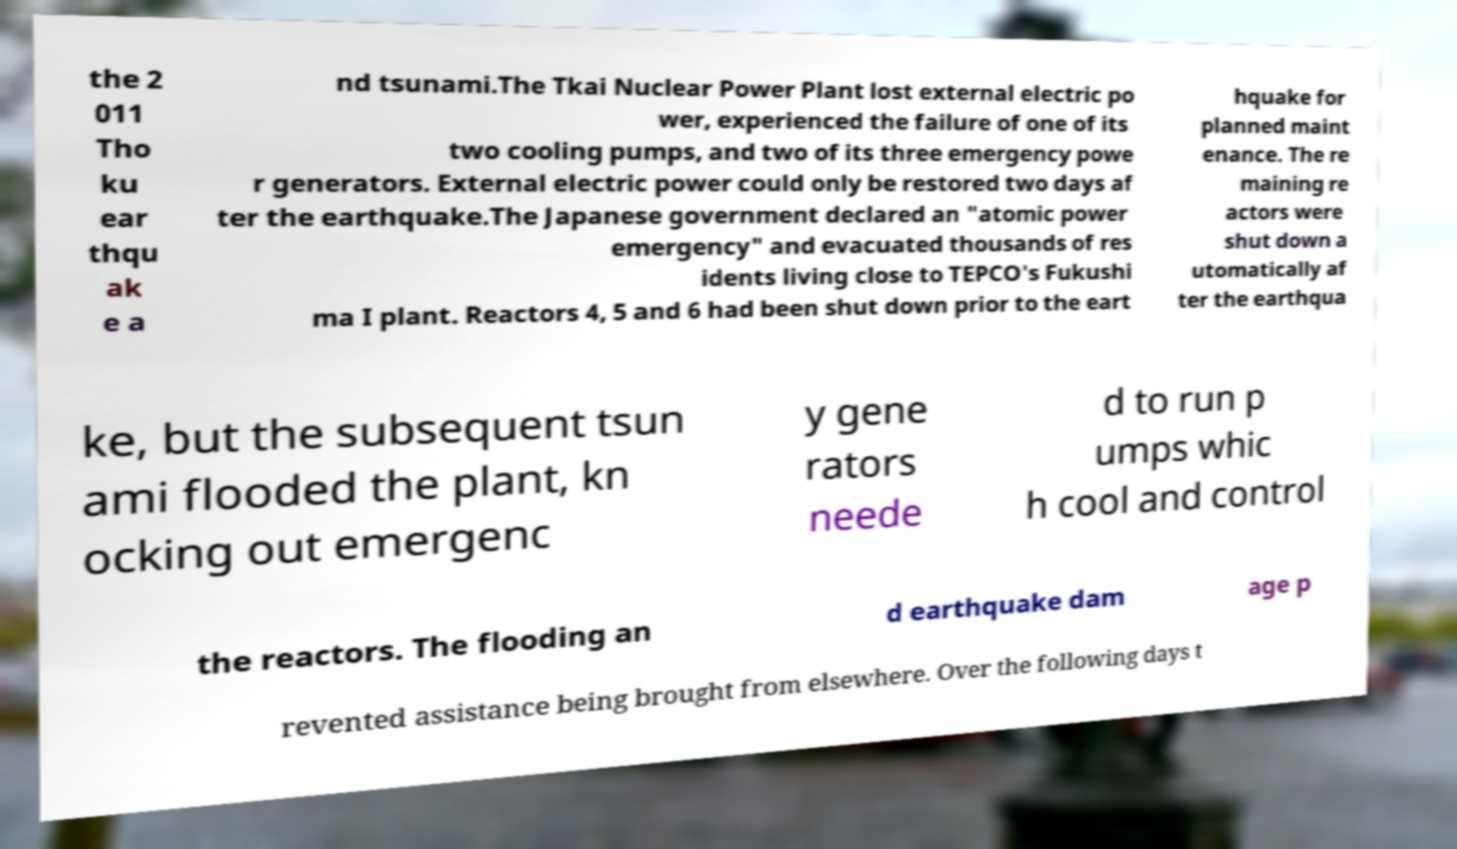Please identify and transcribe the text found in this image. the 2 011 Tho ku ear thqu ak e a nd tsunami.The Tkai Nuclear Power Plant lost external electric po wer, experienced the failure of one of its two cooling pumps, and two of its three emergency powe r generators. External electric power could only be restored two days af ter the earthquake.The Japanese government declared an "atomic power emergency" and evacuated thousands of res idents living close to TEPCO's Fukushi ma I plant. Reactors 4, 5 and 6 had been shut down prior to the eart hquake for planned maint enance. The re maining re actors were shut down a utomatically af ter the earthqua ke, but the subsequent tsun ami flooded the plant, kn ocking out emergenc y gene rators neede d to run p umps whic h cool and control the reactors. The flooding an d earthquake dam age p revented assistance being brought from elsewhere. Over the following days t 